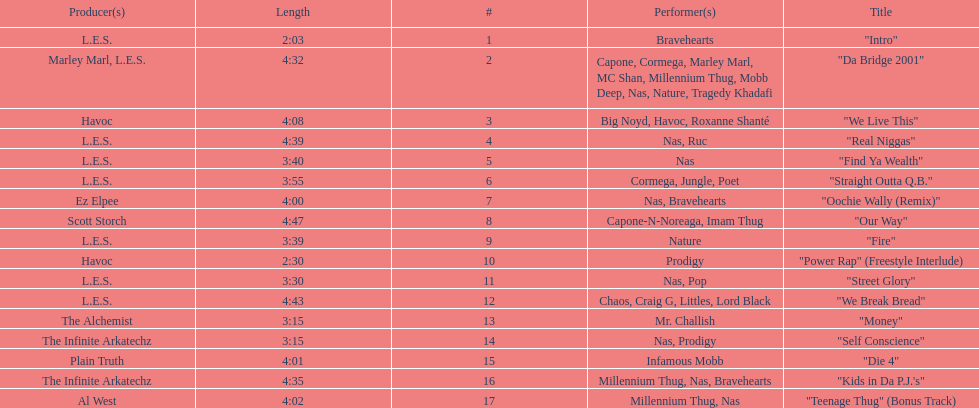What are the track lengths on the album? 2:03, 4:32, 4:08, 4:39, 3:40, 3:55, 4:00, 4:47, 3:39, 2:30, 3:30, 4:43, 3:15, 3:15, 4:01, 4:35, 4:02. What is the longest length? 4:47. 